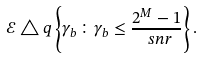<formula> <loc_0><loc_0><loc_500><loc_500>\mathcal { E } \triangle q \left \{ \gamma _ { b } \colon \gamma _ { b } \leq \frac { 2 ^ { M } - 1 } { \ s n r } \right \} .</formula> 